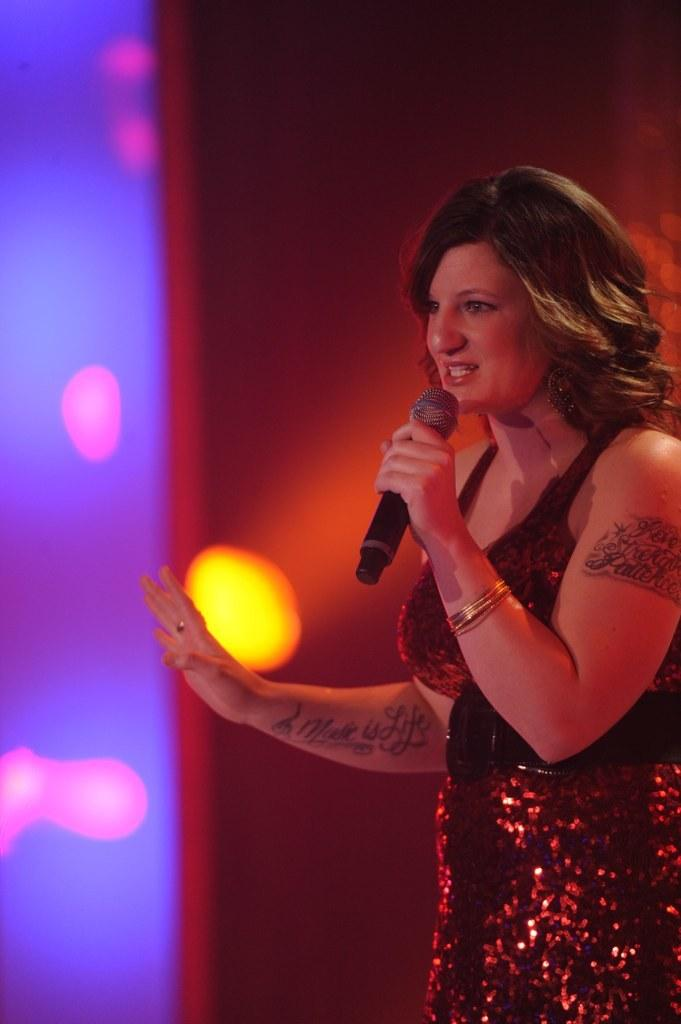What is the main subject of the image? There is a woman in the image. What is the woman holding in the image? The woman is holding a mic. What is the woman doing in the image? The woman is singing. What can be seen in the background of the image? There are lights in the background of the image. Is the woman trying to break a record for the longest skate in the image? There is no indication of a skate or a record-breaking attempt in the image; the woman is holding a mic and singing. 